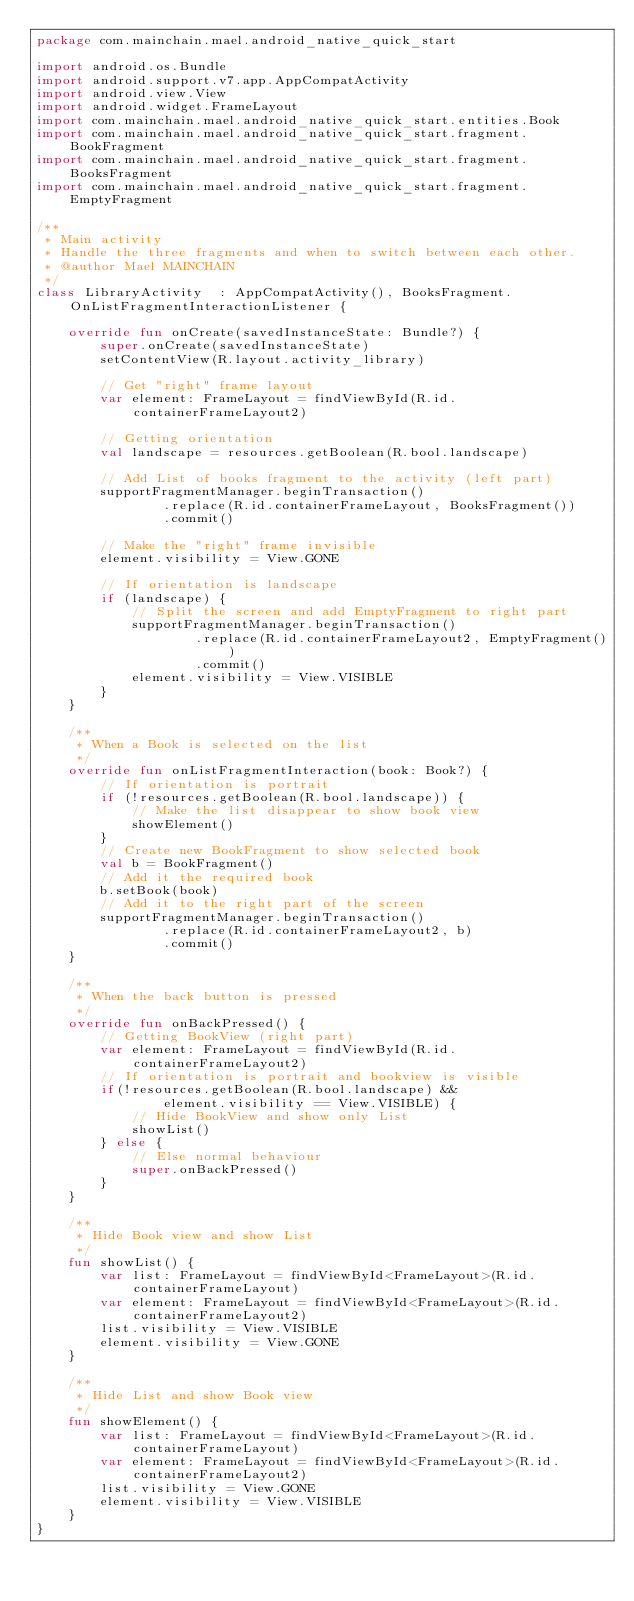<code> <loc_0><loc_0><loc_500><loc_500><_Kotlin_>package com.mainchain.mael.android_native_quick_start

import android.os.Bundle
import android.support.v7.app.AppCompatActivity
import android.view.View
import android.widget.FrameLayout
import com.mainchain.mael.android_native_quick_start.entities.Book
import com.mainchain.mael.android_native_quick_start.fragment.BookFragment
import com.mainchain.mael.android_native_quick_start.fragment.BooksFragment
import com.mainchain.mael.android_native_quick_start.fragment.EmptyFragment

/**
 * Main activity
 * Handle the three fragments and when to switch between each other.
 * @author Mael MAINCHAIN
 */
class LibraryActivity  : AppCompatActivity(), BooksFragment.OnListFragmentInteractionListener {

    override fun onCreate(savedInstanceState: Bundle?) {
        super.onCreate(savedInstanceState)
        setContentView(R.layout.activity_library)

        // Get "right" frame layout
        var element: FrameLayout = findViewById(R.id.containerFrameLayout2)

        // Getting orientation
        val landscape = resources.getBoolean(R.bool.landscape)

        // Add List of books fragment to the activity (left part)
        supportFragmentManager.beginTransaction()
                .replace(R.id.containerFrameLayout, BooksFragment())
                .commit()

        // Make the "right" frame invisible
        element.visibility = View.GONE

        // If orientation is landscape
        if (landscape) {
            // Split the screen and add EmptyFragment to right part
            supportFragmentManager.beginTransaction()
                    .replace(R.id.containerFrameLayout2, EmptyFragment())
                    .commit()
            element.visibility = View.VISIBLE
        }
    }

    /**
     * When a Book is selected on the list
     */
    override fun onListFragmentInteraction(book: Book?) {
        // If orientation is portrait
        if (!resources.getBoolean(R.bool.landscape)) {
            // Make the list disappear to show book view
            showElement()
        }
        // Create new BookFragment to show selected book
        val b = BookFragment()
        // Add it the required book
        b.setBook(book)
        // Add it to the right part of the screen
        supportFragmentManager.beginTransaction()
                .replace(R.id.containerFrameLayout2, b)
                .commit()
    }

    /**
     * When the back button is pressed
     */
    override fun onBackPressed() {
        // Getting BookView (right part)
        var element: FrameLayout = findViewById(R.id.containerFrameLayout2)
        // If orientation is portrait and bookview is visible
        if(!resources.getBoolean(R.bool.landscape) &&
                element.visibility == View.VISIBLE) {
            // Hide BookView and show only List
            showList()
        } else {
            // Else normal behaviour
            super.onBackPressed()
        }
    }

    /**
     * Hide Book view and show List
     */
    fun showList() {
        var list: FrameLayout = findViewById<FrameLayout>(R.id.containerFrameLayout)
        var element: FrameLayout = findViewById<FrameLayout>(R.id.containerFrameLayout2)
        list.visibility = View.VISIBLE
        element.visibility = View.GONE
    }

    /**
     * Hide List and show Book view
     */
    fun showElement() {
        var list: FrameLayout = findViewById<FrameLayout>(R.id.containerFrameLayout)
        var element: FrameLayout = findViewById<FrameLayout>(R.id.containerFrameLayout2)
        list.visibility = View.GONE
        element.visibility = View.VISIBLE
    }
}</code> 